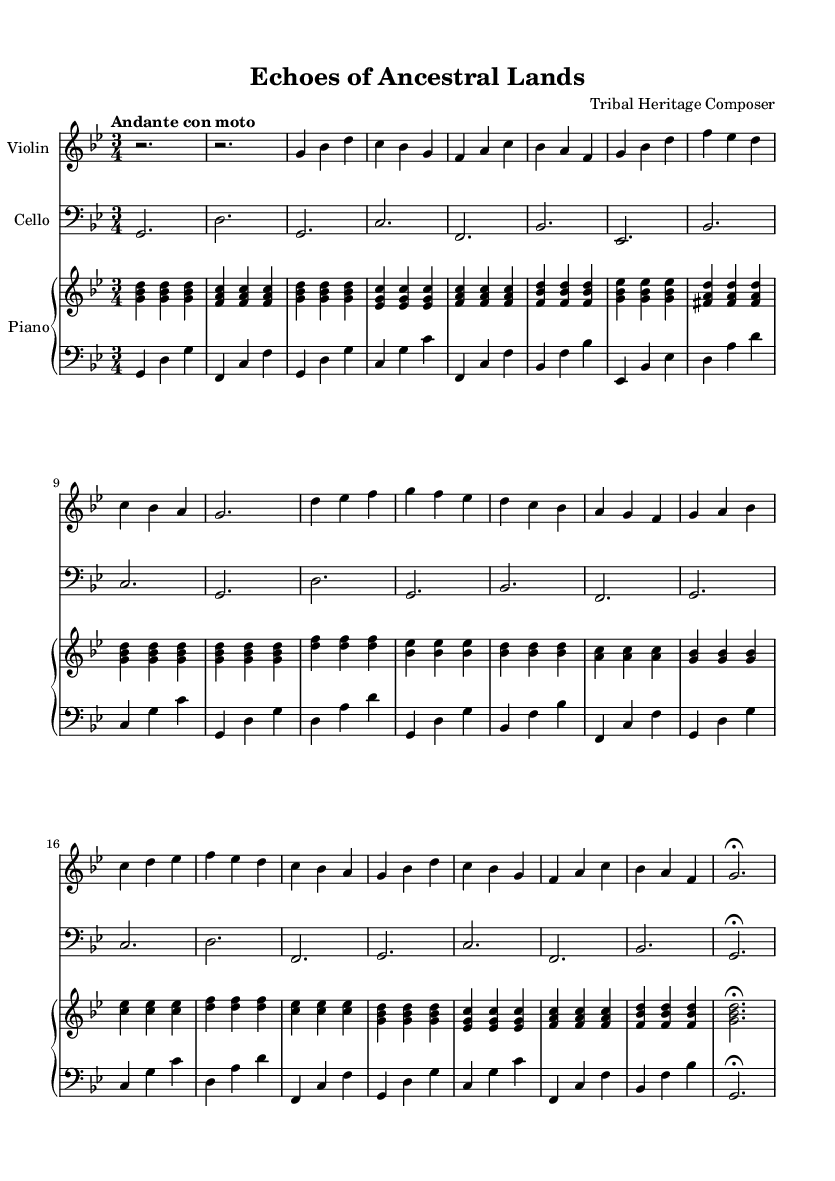what is the key signature of this music? The key signature in this sheet music is indicated at the beginning, showing two flats, which corresponds to the key of G minor.
Answer: G minor what is the time signature of this music? The time signature is displayed at the beginning of the score. It shows 3/4, meaning there are three beats per measure and the quarter note gets one beat.
Answer: 3/4 what is the tempo marking for this piece? The tempo marking is found near the start of the music. It reads "Andante con moto," indicating a moderately slow tempo with a slight movement.
Answer: Andante con moto how many measures are in the A section? To find the number of measures in the A section, we count the measures from the first A section line to the beginning of the B section. There are eight measures in the A section.
Answer: 8 what instruments are featured in this chamber music? The instruments are listed in the score header and can also be discerned from the staves. This piece includes a violin, cello, and piano.
Answer: Violin, cello, piano which section contains the simplified theme? The simplified theme is indicated as A' in the score, which follows the B section and mirrors the main theme but is less complex.
Answer: A' section how does the piano contribute to the texture in this piece? By analyzing the score, the piano has both the right and left hand playing, creating a harmonic and rhythmic foundation that supports the string instruments. The complexity and interplay between hands enhance the overall texture.
Answer: Harmonic foundation 